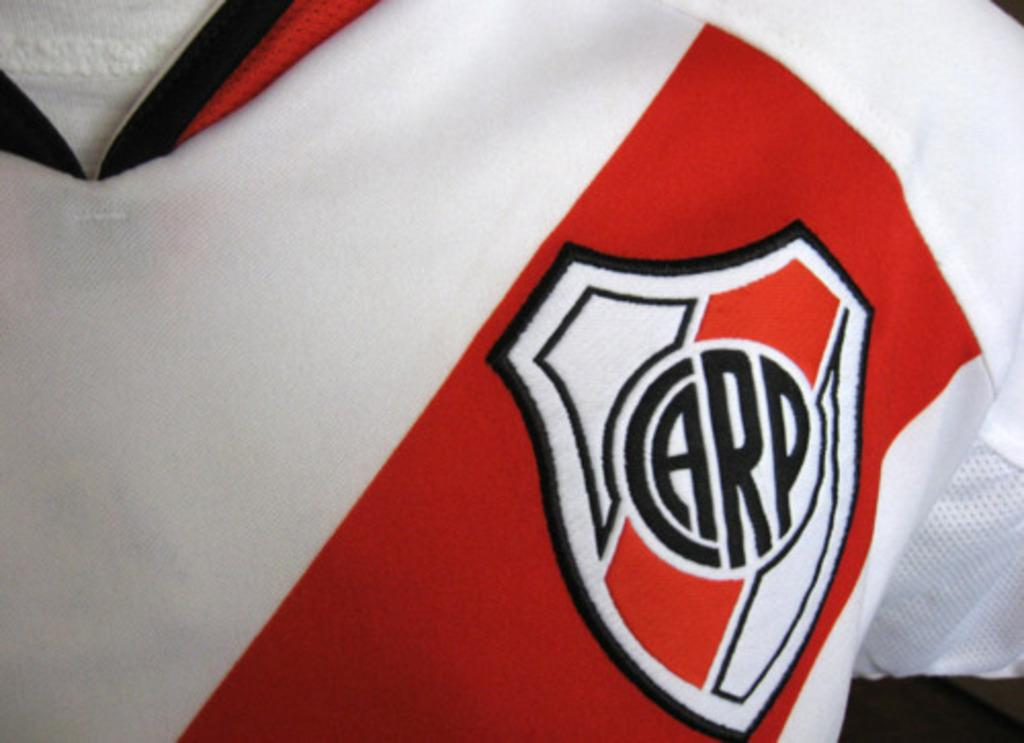<image>
Write a terse but informative summary of the picture. A red and white sports top has a badge with the letters CARP on it. 